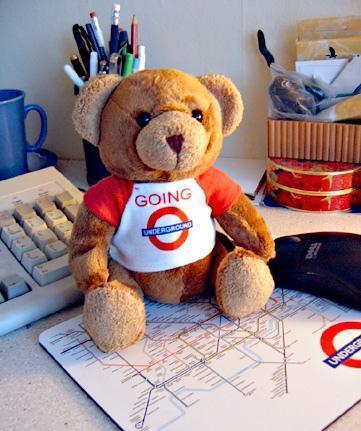How many teddy bears?
Give a very brief answer. 1. How many teddy bears are there?
Give a very brief answer. 1. 